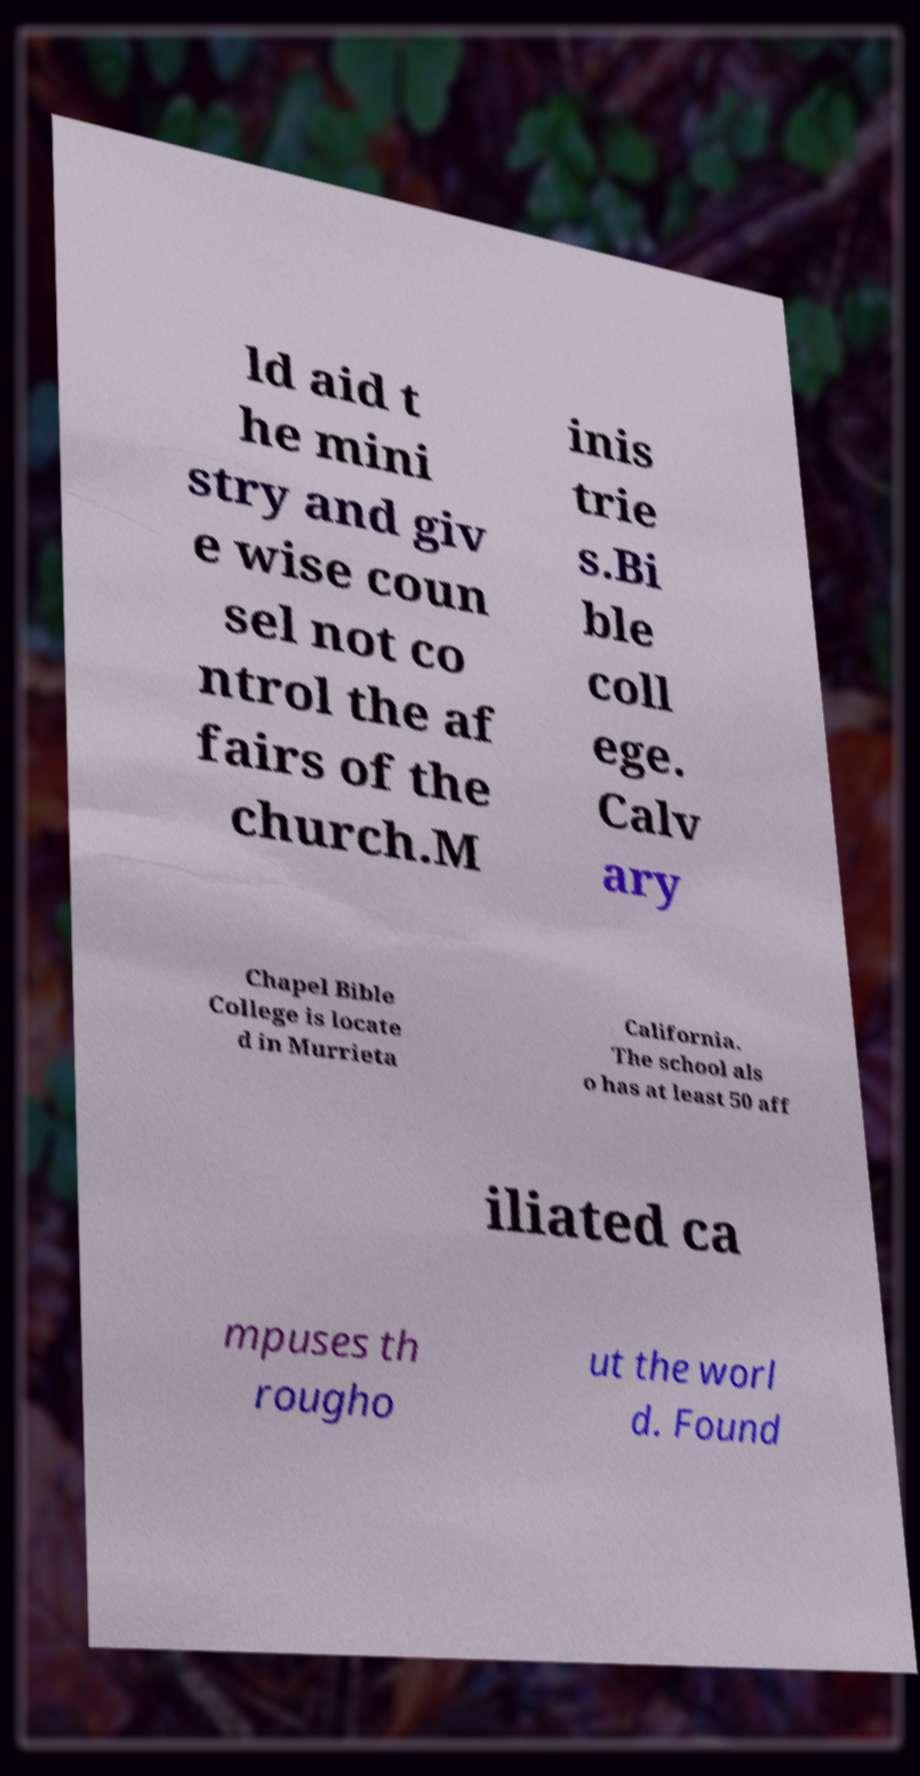Please identify and transcribe the text found in this image. ld aid t he mini stry and giv e wise coun sel not co ntrol the af fairs of the church.M inis trie s.Bi ble coll ege. Calv ary Chapel Bible College is locate d in Murrieta California. The school als o has at least 50 aff iliated ca mpuses th rougho ut the worl d. Found 